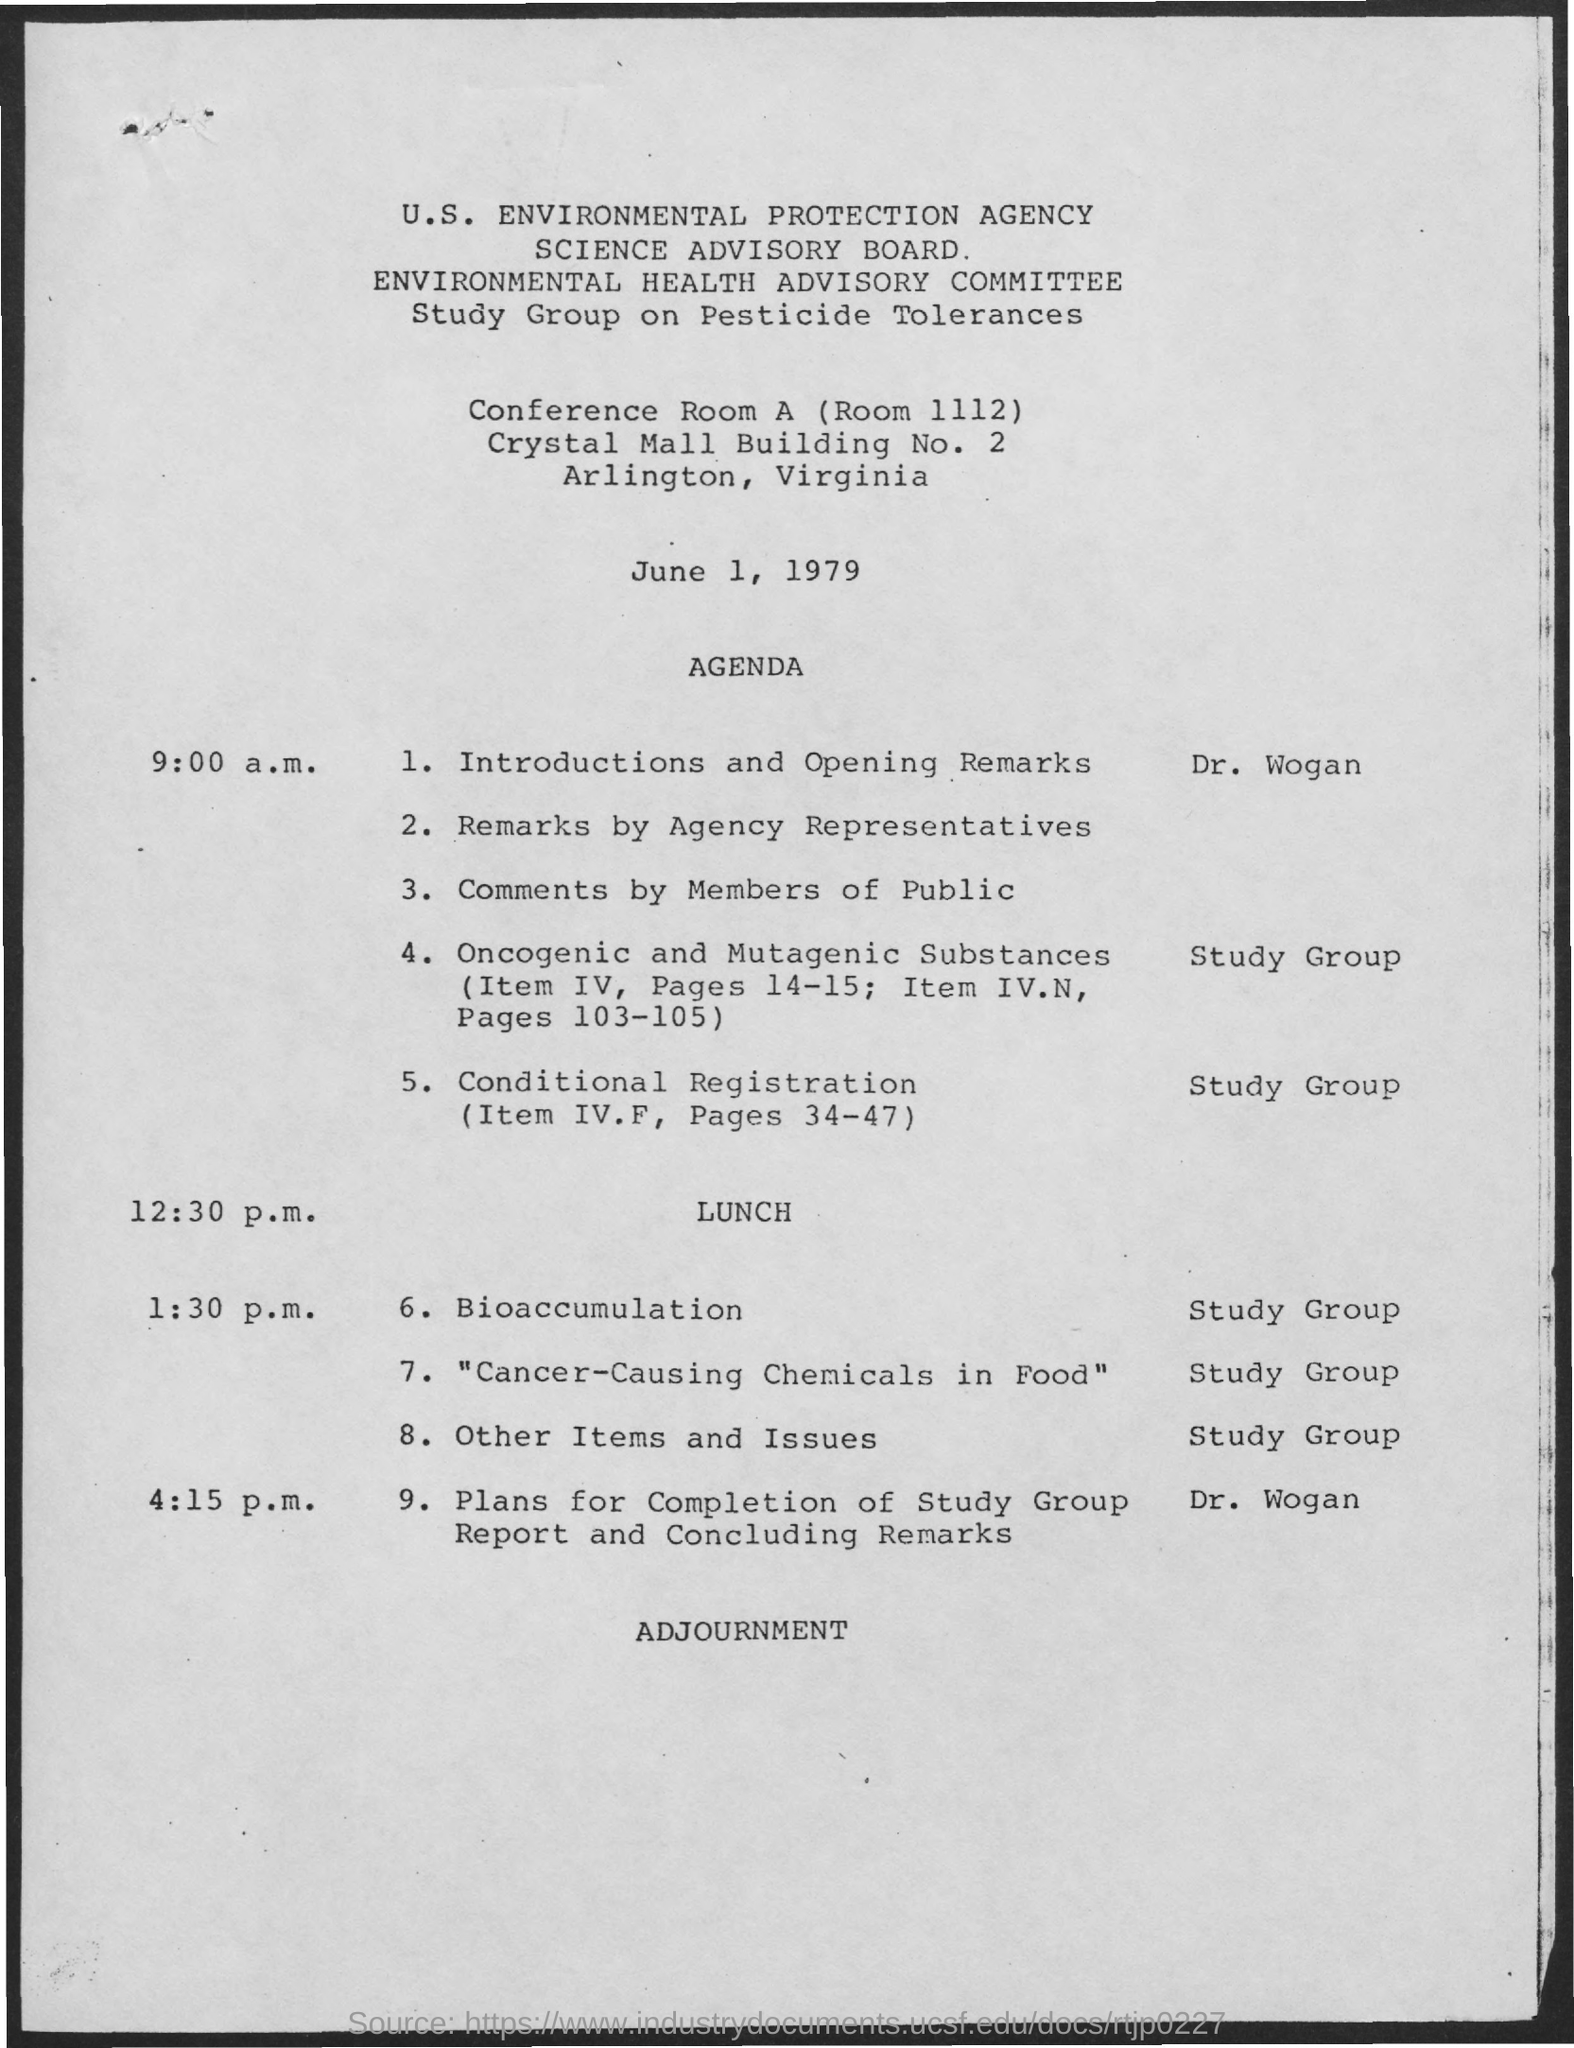What is the conference room number?
Give a very brief answer. Room 1112. What is the date mentioned in the document?
Your answer should be compact. June 1, 1979. What is the building number?
Make the answer very short. 2. Name of the session after lunch?
Your response must be concise. 6. bioaccumulation. Lunch is at which time?
Ensure brevity in your answer.  12:30 p.m. 